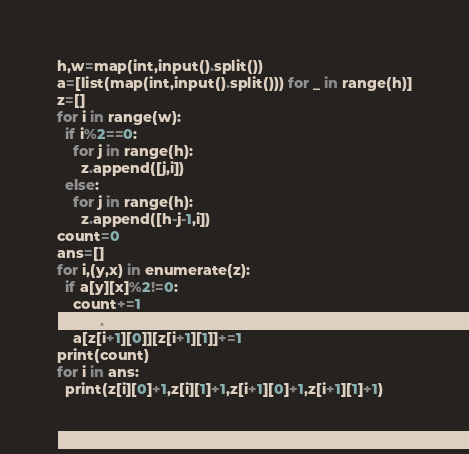<code> <loc_0><loc_0><loc_500><loc_500><_Python_>h,w=map(int,input().split())
a=[list(map(int,input().split())) for _ in range(h)]
z=[]
for i in range(w):
  if i%2==0:
    for j in range(h):
      z.append([j,i])
  else:
    for j in range(h):
      z.append([h-j-1,i])
count=0
ans=[]
for i,(y,x) in enumerate(z):
  if a[y][x]%2!=0:
    count+=1
    ans.append(i)
    a[z[i+1][0]][z[i+1][1]]+=1
print(count)
for i in ans:
  print(z[i][0]+1,z[i][1]+1,z[i+1][0]+1,z[i+1][1]+1)</code> 